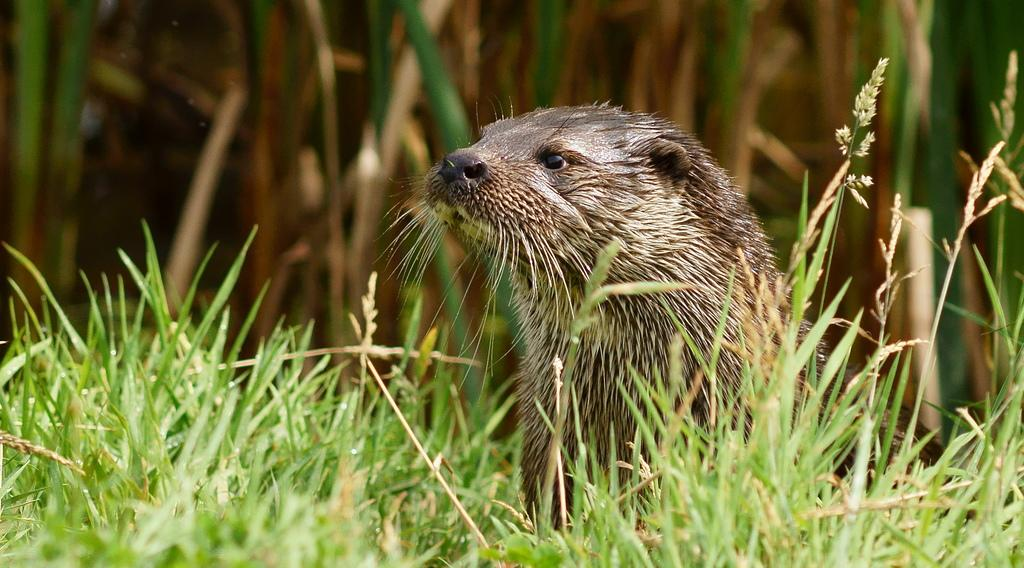What type of animal is in the image? There is an otter in the image. What type of vegetation is present in the image? There is grass in the image. How would you describe the background of the image? The background of the image is blurred. What type of support can be seen in the image? There is no support visible in the image; it features an otter and grass with a blurred background. 